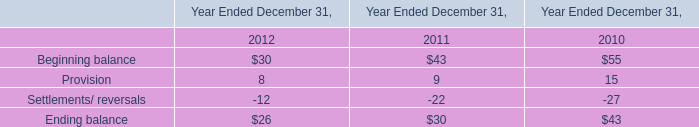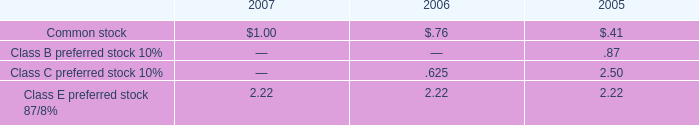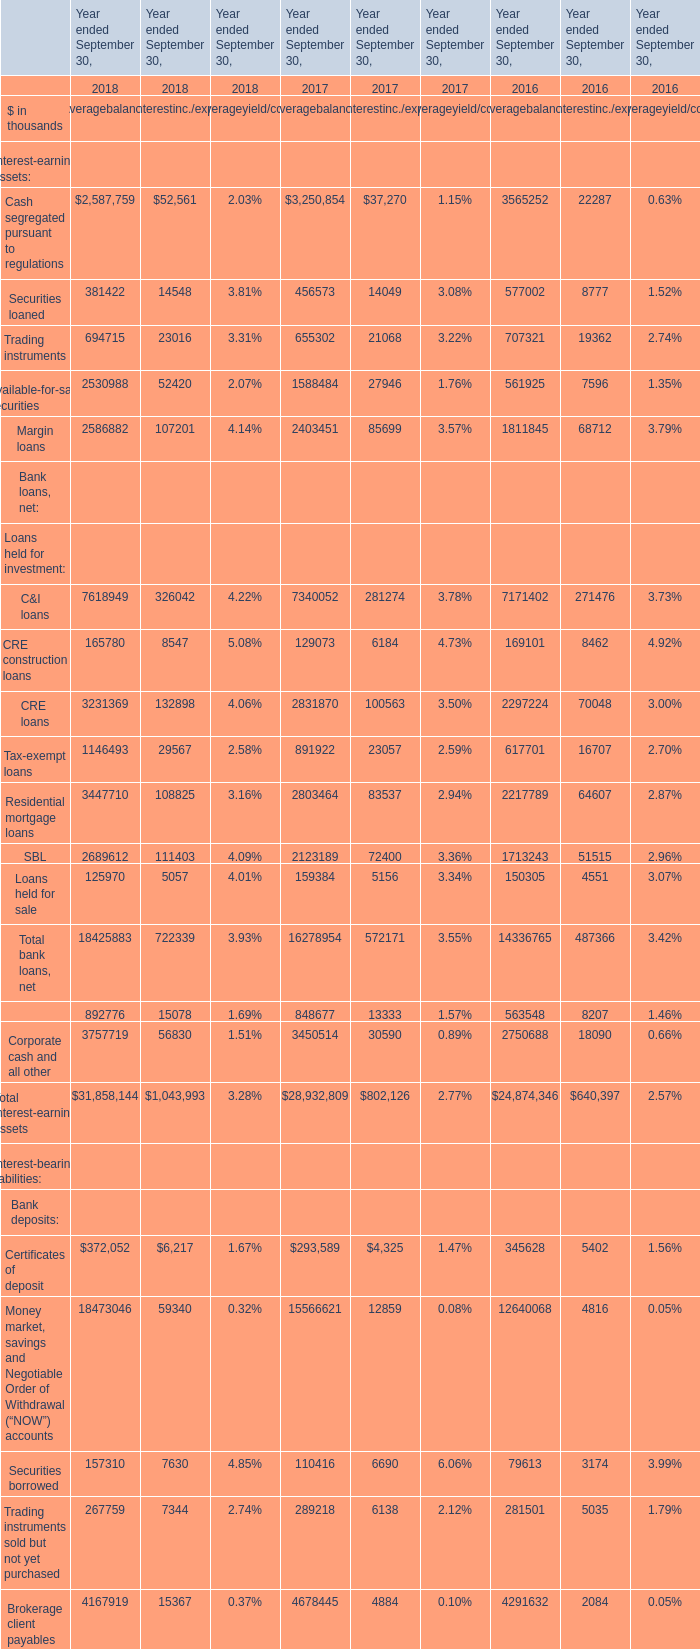what was the percent of the increase in the common stock dividend from 2006 to 2007 
Computations: ((1.00 / .76) / .76)
Answer: 1.7313. 